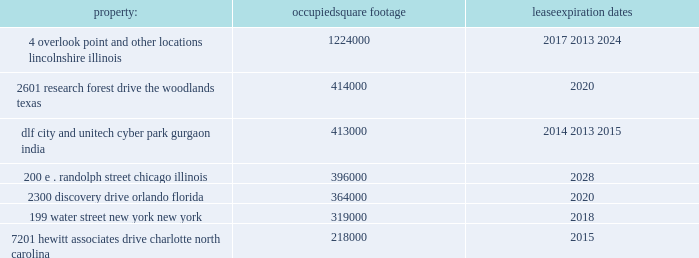Class a ordinary shares of aon plc are , at present , eligible for deposit and clearing within the dtc system .
In connection with the closing of the merger , we entered into arrangements with dtc whereby we agreed to indemnify dtc for any stamp duty and/or sdrt that may be assessed upon it as a result of its service as a depository and clearing agency for our class a ordinary shares .
In addition , we have obtained a ruling from hmrc in respect of the stamp duty and sdrt consequences of the reorganization , and sdrt has been paid in accordance with the terms of this ruling in respect of the deposit of class a ordinary shares with the initial depository .
Dtc will generally have discretion to cease to act as a depository and clearing agency for the class a ordinary shares .
If dtc determines at any time that the class a ordinary shares are not eligible for continued deposit and clearance within its facilities , then we believe the class a ordinary shares would not be eligible for continued listing on a u.s .
Securities exchange or inclusion in the s&p 500 and trading in the class a ordinary shares would be disrupted .
While we would pursue alternative arrangements to preserve our listing and maintain trading , any such disruption could have a material adverse effect on the trading price of the class a ordinary shares .
Item 1b .
Unresolved staff comments .
Item 2 .
Properties .
We have offices in various locations throughout the world .
Substantially all of our offices are located in leased premises .
We maintain our corporate headquarters at 8 devonshire square , london , england , where we occupy approximately 225000 square feet of space under an operating lease agreement that expires in 2018 .
We own one building at pallbergweg 2-4 , amsterdam , the netherlands ( 150000 square feet ) .
The following are additional significant leased properties , along with the occupied square footage and expiration .
Property : occupied square footage expiration .
The locations in lincolnshire , illinois , the woodlands , texas , gurgaon , india , orlando , florida , and charlotte , north carolina , each of which were acquired as part of the hewitt acquisition in 2010 , are primarily dedicated to our hr solutions segment .
The other locations listed above house personnel from both of our reportable segments .
In november 2011 , aon entered into an agreement to lease 190000 square feet in a new building to be constructed in london , united kingdom .
The agreement is contingent upon the completion of the building construction .
Aon expects to move into the new building in 2015 when it exercises an early break option at the devonshire square location .
In september 2013 , aon entered into an agreement to lease up to 479000 square feet in a new building to be constructed in gurgaon , india .
The agreement is contingent upon the completion of the building construction .
Aon expects to move into the new building in phases during 2014 and 2015 upon the expiration of the existing leases at the gurgaon locations .
In general , no difficulty is anticipated in negotiating renewals as leases expire or in finding other satisfactory space if the premises become unavailable .
We believe that the facilities we currently occupy are adequate for the purposes for which they are being used and are well maintained .
In certain circumstances , we may have unused space and may seek to sublet such space to third parties , depending upon the demands for office space in the locations involved .
See note 9 "lease commitments" of the notes to consolidated financial statements in part ii , item 8 of this report for information with respect to our lease commitments as of december 31 , 2013 .
Item 3 .
Legal proceedings .
We hereby incorporate by reference note 16 "commitments and contingencies" of the notes to consolidated financial statements in part ii , item 8 of this report. .
How many square feet of the occupied space will expire during 2020? 
Computations: (414000 + 364000)
Answer: 778000.0. 